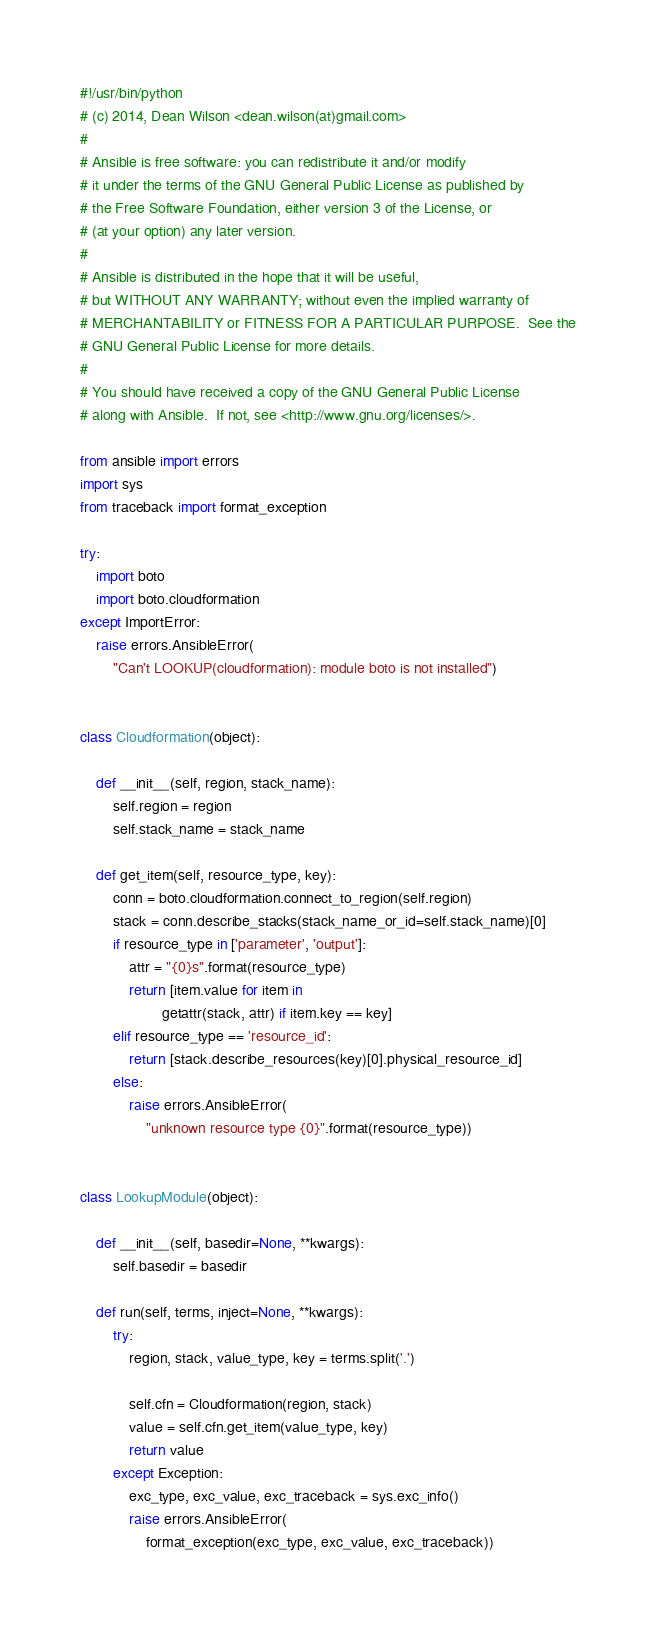<code> <loc_0><loc_0><loc_500><loc_500><_Python_>#!/usr/bin/python
# (c) 2014, Dean Wilson <dean.wilson(at)gmail.com>
#
# Ansible is free software: you can redistribute it and/or modify
# it under the terms of the GNU General Public License as published by
# the Free Software Foundation, either version 3 of the License, or
# (at your option) any later version.
#
# Ansible is distributed in the hope that it will be useful,
# but WITHOUT ANY WARRANTY; without even the implied warranty of
# MERCHANTABILITY or FITNESS FOR A PARTICULAR PURPOSE.  See the
# GNU General Public License for more details.
#
# You should have received a copy of the GNU General Public License
# along with Ansible.  If not, see <http://www.gnu.org/licenses/>.

from ansible import errors
import sys
from traceback import format_exception

try:
    import boto
    import boto.cloudformation
except ImportError:
    raise errors.AnsibleError(
        "Can't LOOKUP(cloudformation): module boto is not installed")


class Cloudformation(object):

    def __init__(self, region, stack_name):
        self.region = region
        self.stack_name = stack_name

    def get_item(self, resource_type, key):
        conn = boto.cloudformation.connect_to_region(self.region)
        stack = conn.describe_stacks(stack_name_or_id=self.stack_name)[0]
        if resource_type in ['parameter', 'output']:
            attr = "{0}s".format(resource_type)
            return [item.value for item in
                    getattr(stack, attr) if item.key == key]
        elif resource_type == 'resource_id':
            return [stack.describe_resources(key)[0].physical_resource_id]
        else:
            raise errors.AnsibleError(
                "unknown resource type {0}".format(resource_type))


class LookupModule(object):

    def __init__(self, basedir=None, **kwargs):
        self.basedir = basedir

    def run(self, terms, inject=None, **kwargs):
        try:
            region, stack, value_type, key = terms.split('.')

            self.cfn = Cloudformation(region, stack)
            value = self.cfn.get_item(value_type, key)
            return value
        except Exception:
            exc_type, exc_value, exc_traceback = sys.exc_info()
            raise errors.AnsibleError(
                format_exception(exc_type, exc_value, exc_traceback))
</code> 